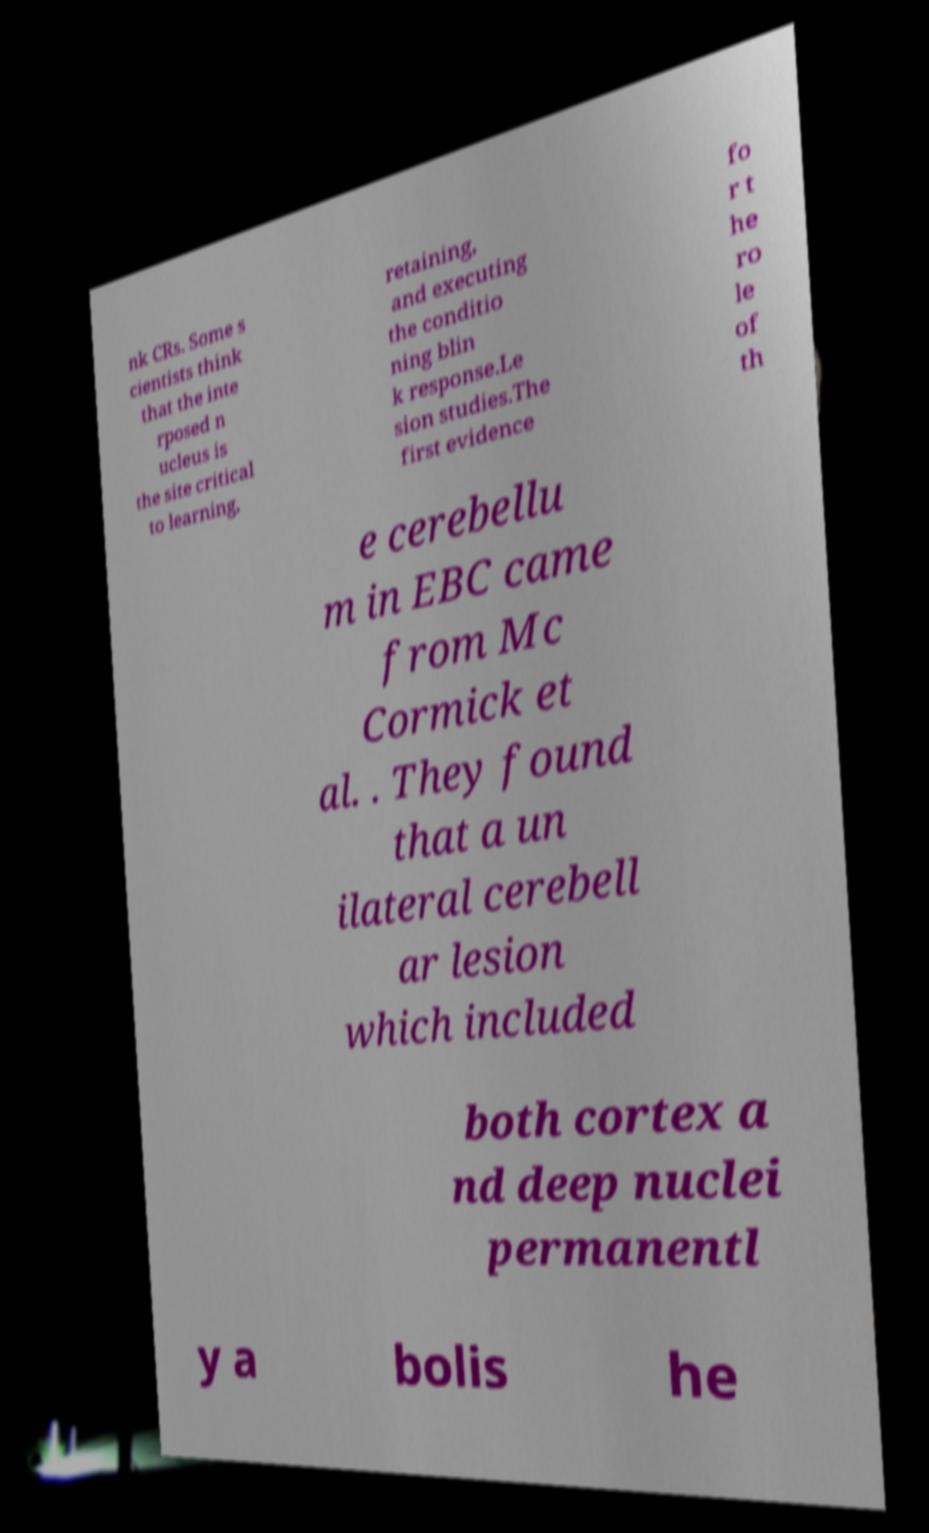Can you read and provide the text displayed in the image?This photo seems to have some interesting text. Can you extract and type it out for me? nk CRs. Some s cientists think that the inte rposed n ucleus is the site critical to learning, retaining, and executing the conditio ning blin k response.Le sion studies.The first evidence fo r t he ro le of th e cerebellu m in EBC came from Mc Cormick et al. . They found that a un ilateral cerebell ar lesion which included both cortex a nd deep nuclei permanentl y a bolis he 